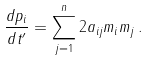Convert formula to latex. <formula><loc_0><loc_0><loc_500><loc_500>\frac { d p _ { i } } { d t ^ { \prime } } = \sum _ { j = 1 } ^ { n } 2 a _ { i j } m _ { i } m _ { j } \, .</formula> 